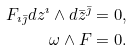<formula> <loc_0><loc_0><loc_500><loc_500>F _ { \imath \bar { \jmath } } d z ^ { \imath } \wedge d { \bar { z } } ^ { \bar { \jmath } } = 0 , \\ \omega \wedge F = 0 .</formula> 